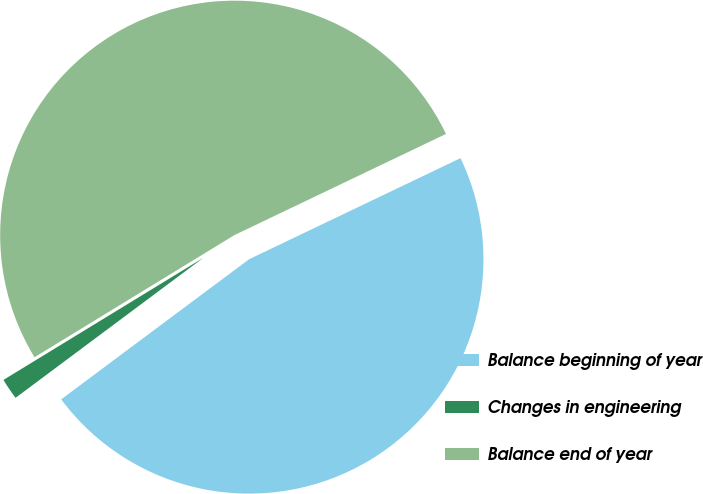Convert chart. <chart><loc_0><loc_0><loc_500><loc_500><pie_chart><fcel>Balance beginning of year<fcel>Changes in engineering<fcel>Balance end of year<nl><fcel>46.9%<fcel>1.47%<fcel>51.63%<nl></chart> 